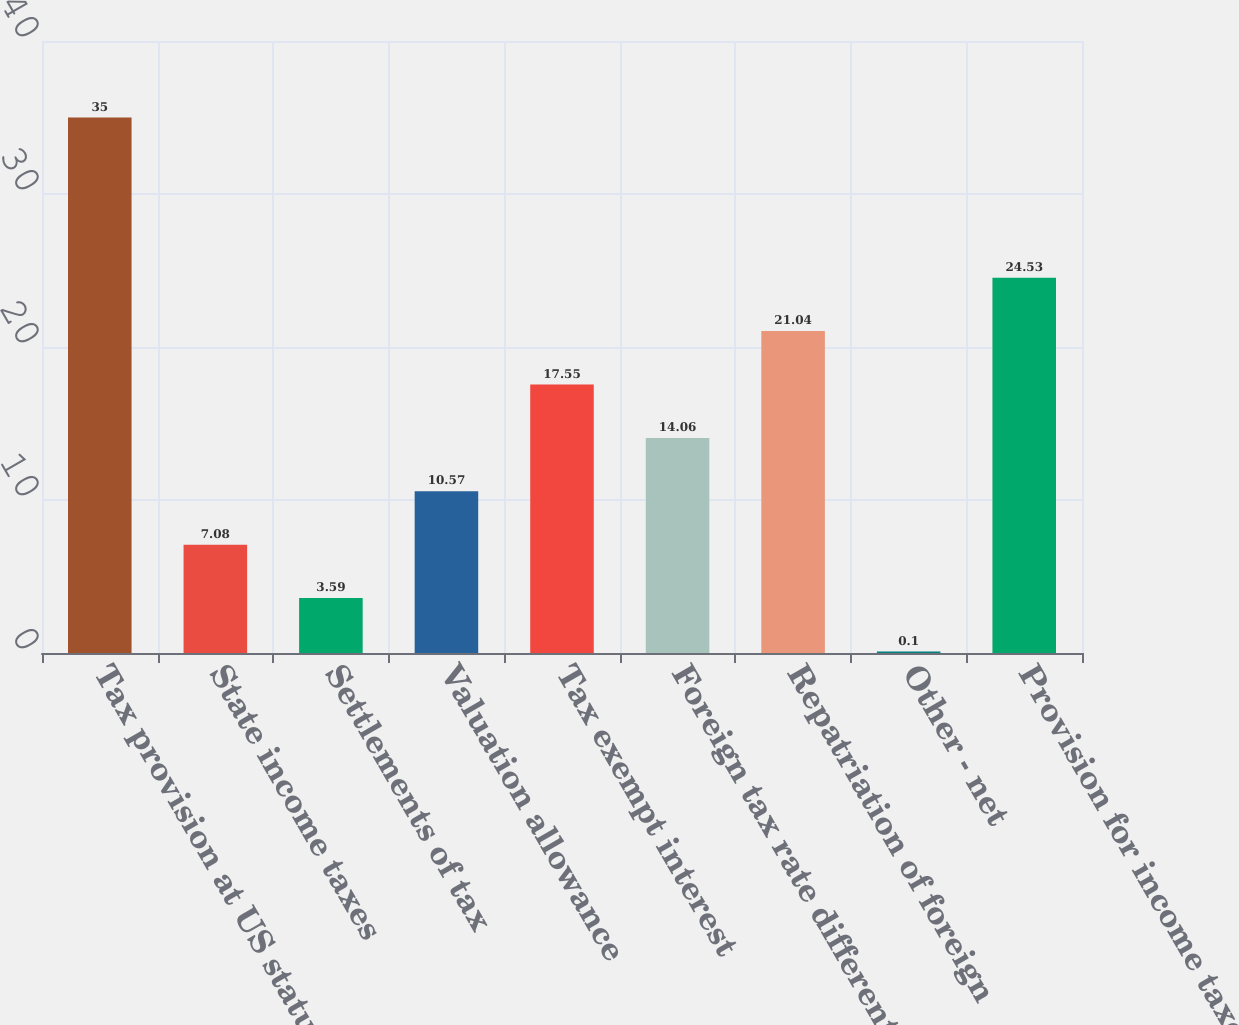Convert chart to OTSL. <chart><loc_0><loc_0><loc_500><loc_500><bar_chart><fcel>Tax provision at US statutory<fcel>State income taxes<fcel>Settlements of tax<fcel>Valuation allowance<fcel>Tax exempt interest<fcel>Foreign tax rate differential<fcel>Repatriation of foreign<fcel>Other - net<fcel>Provision for income taxes<nl><fcel>35<fcel>7.08<fcel>3.59<fcel>10.57<fcel>17.55<fcel>14.06<fcel>21.04<fcel>0.1<fcel>24.53<nl></chart> 